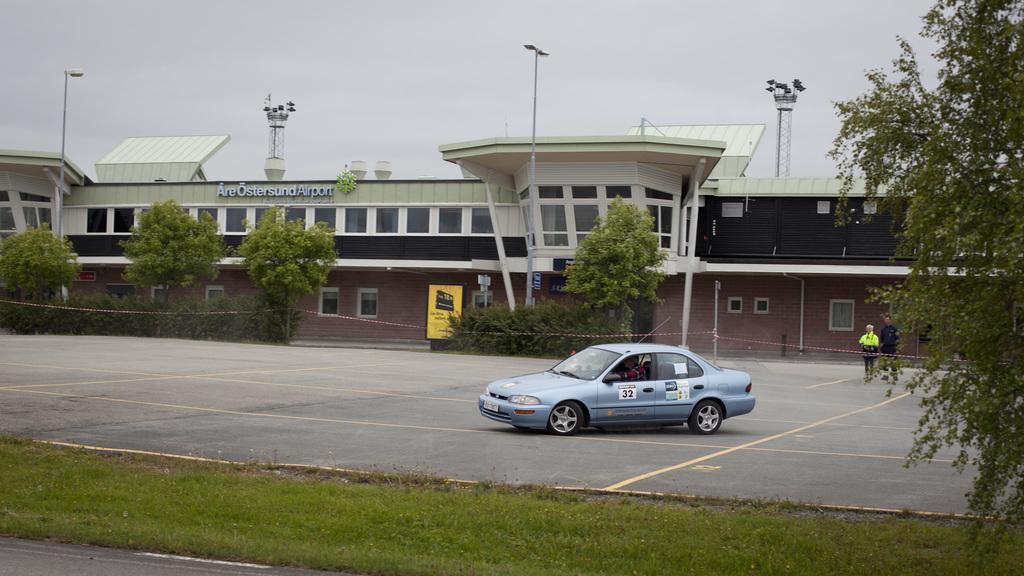How would you summarize this image in a sentence or two? In this picture I can see a vehicle on the road, few people standing a side, around there are some trees and buildings. 